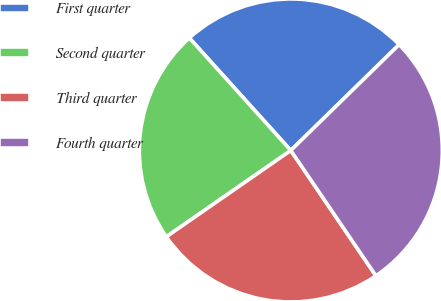<chart> <loc_0><loc_0><loc_500><loc_500><pie_chart><fcel>First quarter<fcel>Second quarter<fcel>Third quarter<fcel>Fourth quarter<nl><fcel>24.36%<fcel>22.97%<fcel>24.84%<fcel>27.82%<nl></chart> 